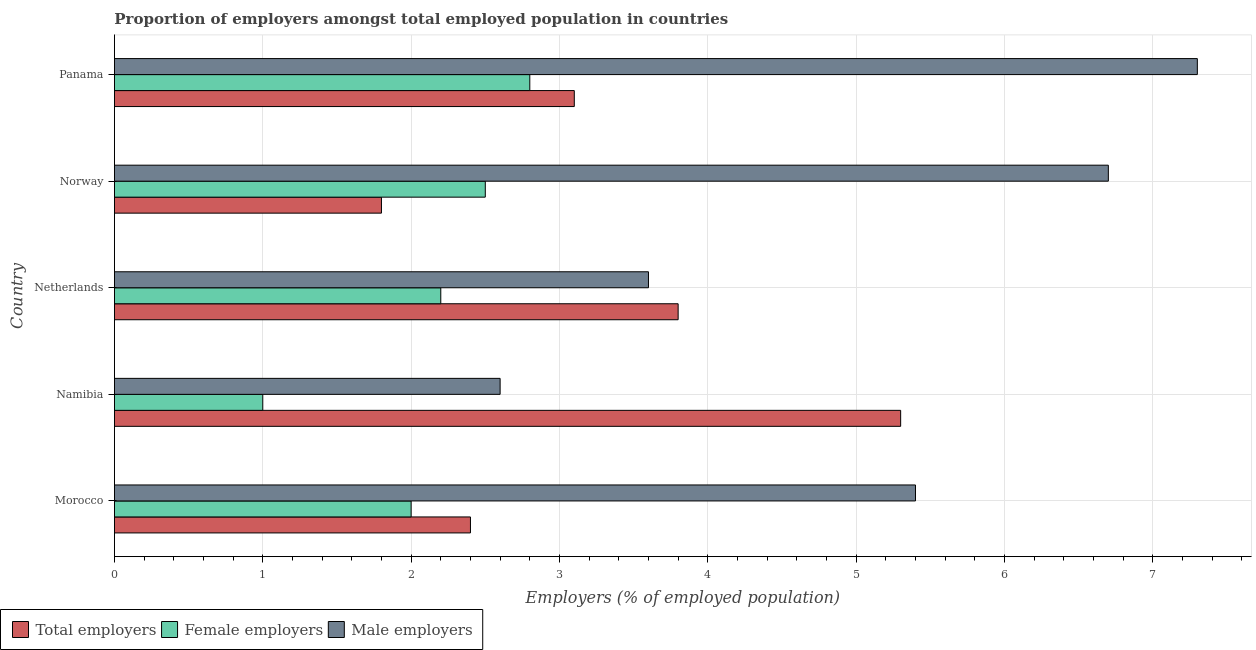How many groups of bars are there?
Ensure brevity in your answer.  5. Are the number of bars on each tick of the Y-axis equal?
Make the answer very short. Yes. How many bars are there on the 4th tick from the bottom?
Make the answer very short. 3. What is the label of the 5th group of bars from the top?
Offer a terse response. Morocco. In how many cases, is the number of bars for a given country not equal to the number of legend labels?
Your answer should be very brief. 0. Across all countries, what is the maximum percentage of total employers?
Offer a very short reply. 5.3. Across all countries, what is the minimum percentage of total employers?
Make the answer very short. 1.8. In which country was the percentage of male employers maximum?
Provide a short and direct response. Panama. In which country was the percentage of male employers minimum?
Your answer should be very brief. Namibia. What is the total percentage of female employers in the graph?
Ensure brevity in your answer.  10.5. What is the difference between the percentage of female employers in Namibia and that in Norway?
Provide a short and direct response. -1.5. What is the difference between the percentage of female employers in Panama and the percentage of total employers in Morocco?
Keep it short and to the point. 0.4. What is the average percentage of total employers per country?
Provide a short and direct response. 3.28. What is the difference between the percentage of female employers and percentage of total employers in Namibia?
Your answer should be very brief. -4.3. In how many countries, is the percentage of female employers greater than 7.4 %?
Your response must be concise. 0. What is the ratio of the percentage of female employers in Netherlands to that in Panama?
Provide a short and direct response. 0.79. Is the percentage of total employers in Namibia less than that in Norway?
Your answer should be compact. No. Is the difference between the percentage of male employers in Morocco and Namibia greater than the difference between the percentage of female employers in Morocco and Namibia?
Provide a succinct answer. Yes. In how many countries, is the percentage of male employers greater than the average percentage of male employers taken over all countries?
Your answer should be very brief. 3. What does the 2nd bar from the top in Netherlands represents?
Ensure brevity in your answer.  Female employers. What does the 2nd bar from the bottom in Netherlands represents?
Offer a terse response. Female employers. How many bars are there?
Ensure brevity in your answer.  15. How many countries are there in the graph?
Your answer should be compact. 5. What is the difference between two consecutive major ticks on the X-axis?
Ensure brevity in your answer.  1. Are the values on the major ticks of X-axis written in scientific E-notation?
Provide a succinct answer. No. How are the legend labels stacked?
Your response must be concise. Horizontal. What is the title of the graph?
Make the answer very short. Proportion of employers amongst total employed population in countries. Does "Grants" appear as one of the legend labels in the graph?
Give a very brief answer. No. What is the label or title of the X-axis?
Offer a very short reply. Employers (% of employed population). What is the Employers (% of employed population) in Total employers in Morocco?
Your answer should be very brief. 2.4. What is the Employers (% of employed population) in Male employers in Morocco?
Your answer should be very brief. 5.4. What is the Employers (% of employed population) in Total employers in Namibia?
Provide a succinct answer. 5.3. What is the Employers (% of employed population) in Male employers in Namibia?
Provide a succinct answer. 2.6. What is the Employers (% of employed population) of Total employers in Netherlands?
Your answer should be compact. 3.8. What is the Employers (% of employed population) in Female employers in Netherlands?
Your response must be concise. 2.2. What is the Employers (% of employed population) of Male employers in Netherlands?
Keep it short and to the point. 3.6. What is the Employers (% of employed population) in Total employers in Norway?
Make the answer very short. 1.8. What is the Employers (% of employed population) in Female employers in Norway?
Your answer should be very brief. 2.5. What is the Employers (% of employed population) of Male employers in Norway?
Keep it short and to the point. 6.7. What is the Employers (% of employed population) in Total employers in Panama?
Your response must be concise. 3.1. What is the Employers (% of employed population) of Female employers in Panama?
Offer a very short reply. 2.8. What is the Employers (% of employed population) in Male employers in Panama?
Keep it short and to the point. 7.3. Across all countries, what is the maximum Employers (% of employed population) in Total employers?
Ensure brevity in your answer.  5.3. Across all countries, what is the maximum Employers (% of employed population) of Female employers?
Your answer should be very brief. 2.8. Across all countries, what is the maximum Employers (% of employed population) in Male employers?
Your answer should be compact. 7.3. Across all countries, what is the minimum Employers (% of employed population) of Total employers?
Give a very brief answer. 1.8. Across all countries, what is the minimum Employers (% of employed population) of Male employers?
Make the answer very short. 2.6. What is the total Employers (% of employed population) of Total employers in the graph?
Offer a terse response. 16.4. What is the total Employers (% of employed population) of Female employers in the graph?
Your answer should be very brief. 10.5. What is the total Employers (% of employed population) of Male employers in the graph?
Offer a very short reply. 25.6. What is the difference between the Employers (% of employed population) in Female employers in Morocco and that in Netherlands?
Provide a succinct answer. -0.2. What is the difference between the Employers (% of employed population) of Total employers in Morocco and that in Norway?
Ensure brevity in your answer.  0.6. What is the difference between the Employers (% of employed population) of Female employers in Morocco and that in Norway?
Your answer should be compact. -0.5. What is the difference between the Employers (% of employed population) of Male employers in Morocco and that in Norway?
Your response must be concise. -1.3. What is the difference between the Employers (% of employed population) of Total employers in Morocco and that in Panama?
Make the answer very short. -0.7. What is the difference between the Employers (% of employed population) of Male employers in Morocco and that in Panama?
Provide a succinct answer. -1.9. What is the difference between the Employers (% of employed population) of Female employers in Namibia and that in Netherlands?
Ensure brevity in your answer.  -1.2. What is the difference between the Employers (% of employed population) in Male employers in Namibia and that in Netherlands?
Provide a succinct answer. -1. What is the difference between the Employers (% of employed population) in Male employers in Namibia and that in Norway?
Your answer should be very brief. -4.1. What is the difference between the Employers (% of employed population) of Female employers in Namibia and that in Panama?
Offer a terse response. -1.8. What is the difference between the Employers (% of employed population) in Total employers in Netherlands and that in Norway?
Provide a succinct answer. 2. What is the difference between the Employers (% of employed population) of Male employers in Netherlands and that in Norway?
Provide a short and direct response. -3.1. What is the difference between the Employers (% of employed population) in Female employers in Netherlands and that in Panama?
Keep it short and to the point. -0.6. What is the difference between the Employers (% of employed population) in Total employers in Norway and that in Panama?
Provide a succinct answer. -1.3. What is the difference between the Employers (% of employed population) in Male employers in Norway and that in Panama?
Ensure brevity in your answer.  -0.6. What is the difference between the Employers (% of employed population) of Total employers in Morocco and the Employers (% of employed population) of Male employers in Namibia?
Provide a succinct answer. -0.2. What is the difference between the Employers (% of employed population) of Female employers in Morocco and the Employers (% of employed population) of Male employers in Namibia?
Offer a terse response. -0.6. What is the difference between the Employers (% of employed population) in Total employers in Morocco and the Employers (% of employed population) in Female employers in Netherlands?
Make the answer very short. 0.2. What is the difference between the Employers (% of employed population) in Female employers in Morocco and the Employers (% of employed population) in Male employers in Netherlands?
Provide a short and direct response. -1.6. What is the difference between the Employers (% of employed population) in Total employers in Morocco and the Employers (% of employed population) in Female employers in Norway?
Offer a terse response. -0.1. What is the difference between the Employers (% of employed population) in Total employers in Morocco and the Employers (% of employed population) in Female employers in Panama?
Your answer should be compact. -0.4. What is the difference between the Employers (% of employed population) of Female employers in Morocco and the Employers (% of employed population) of Male employers in Panama?
Ensure brevity in your answer.  -5.3. What is the difference between the Employers (% of employed population) in Total employers in Namibia and the Employers (% of employed population) in Female employers in Netherlands?
Offer a very short reply. 3.1. What is the difference between the Employers (% of employed population) in Female employers in Namibia and the Employers (% of employed population) in Male employers in Netherlands?
Provide a succinct answer. -2.6. What is the difference between the Employers (% of employed population) in Total employers in Namibia and the Employers (% of employed population) in Female employers in Panama?
Ensure brevity in your answer.  2.5. What is the difference between the Employers (% of employed population) of Total employers in Namibia and the Employers (% of employed population) of Male employers in Panama?
Your response must be concise. -2. What is the difference between the Employers (% of employed population) of Female employers in Namibia and the Employers (% of employed population) of Male employers in Panama?
Make the answer very short. -6.3. What is the difference between the Employers (% of employed population) in Total employers in Netherlands and the Employers (% of employed population) in Male employers in Norway?
Your answer should be very brief. -2.9. What is the difference between the Employers (% of employed population) in Total employers in Netherlands and the Employers (% of employed population) in Female employers in Panama?
Your answer should be very brief. 1. What is the difference between the Employers (% of employed population) in Total employers in Norway and the Employers (% of employed population) in Female employers in Panama?
Your response must be concise. -1. What is the average Employers (% of employed population) of Total employers per country?
Make the answer very short. 3.28. What is the average Employers (% of employed population) of Male employers per country?
Provide a short and direct response. 5.12. What is the difference between the Employers (% of employed population) in Total employers and Employers (% of employed population) in Male employers in Morocco?
Offer a very short reply. -3. What is the difference between the Employers (% of employed population) of Total employers and Employers (% of employed population) of Male employers in Namibia?
Make the answer very short. 2.7. What is the difference between the Employers (% of employed population) of Total employers and Employers (% of employed population) of Female employers in Norway?
Make the answer very short. -0.7. What is the difference between the Employers (% of employed population) in Female employers and Employers (% of employed population) in Male employers in Norway?
Your answer should be compact. -4.2. What is the ratio of the Employers (% of employed population) in Total employers in Morocco to that in Namibia?
Keep it short and to the point. 0.45. What is the ratio of the Employers (% of employed population) in Female employers in Morocco to that in Namibia?
Offer a terse response. 2. What is the ratio of the Employers (% of employed population) in Male employers in Morocco to that in Namibia?
Your answer should be very brief. 2.08. What is the ratio of the Employers (% of employed population) in Total employers in Morocco to that in Netherlands?
Provide a succinct answer. 0.63. What is the ratio of the Employers (% of employed population) of Female employers in Morocco to that in Netherlands?
Provide a short and direct response. 0.91. What is the ratio of the Employers (% of employed population) in Male employers in Morocco to that in Netherlands?
Your answer should be very brief. 1.5. What is the ratio of the Employers (% of employed population) in Male employers in Morocco to that in Norway?
Offer a terse response. 0.81. What is the ratio of the Employers (% of employed population) of Total employers in Morocco to that in Panama?
Provide a succinct answer. 0.77. What is the ratio of the Employers (% of employed population) of Female employers in Morocco to that in Panama?
Your answer should be very brief. 0.71. What is the ratio of the Employers (% of employed population) in Male employers in Morocco to that in Panama?
Ensure brevity in your answer.  0.74. What is the ratio of the Employers (% of employed population) of Total employers in Namibia to that in Netherlands?
Your response must be concise. 1.39. What is the ratio of the Employers (% of employed population) of Female employers in Namibia to that in Netherlands?
Provide a succinct answer. 0.45. What is the ratio of the Employers (% of employed population) of Male employers in Namibia to that in Netherlands?
Give a very brief answer. 0.72. What is the ratio of the Employers (% of employed population) in Total employers in Namibia to that in Norway?
Offer a very short reply. 2.94. What is the ratio of the Employers (% of employed population) of Female employers in Namibia to that in Norway?
Offer a terse response. 0.4. What is the ratio of the Employers (% of employed population) of Male employers in Namibia to that in Norway?
Offer a very short reply. 0.39. What is the ratio of the Employers (% of employed population) of Total employers in Namibia to that in Panama?
Your response must be concise. 1.71. What is the ratio of the Employers (% of employed population) of Female employers in Namibia to that in Panama?
Your answer should be very brief. 0.36. What is the ratio of the Employers (% of employed population) of Male employers in Namibia to that in Panama?
Keep it short and to the point. 0.36. What is the ratio of the Employers (% of employed population) of Total employers in Netherlands to that in Norway?
Offer a terse response. 2.11. What is the ratio of the Employers (% of employed population) in Male employers in Netherlands to that in Norway?
Keep it short and to the point. 0.54. What is the ratio of the Employers (% of employed population) of Total employers in Netherlands to that in Panama?
Offer a terse response. 1.23. What is the ratio of the Employers (% of employed population) in Female employers in Netherlands to that in Panama?
Your answer should be very brief. 0.79. What is the ratio of the Employers (% of employed population) of Male employers in Netherlands to that in Panama?
Provide a short and direct response. 0.49. What is the ratio of the Employers (% of employed population) of Total employers in Norway to that in Panama?
Your answer should be compact. 0.58. What is the ratio of the Employers (% of employed population) in Female employers in Norway to that in Panama?
Provide a succinct answer. 0.89. What is the ratio of the Employers (% of employed population) of Male employers in Norway to that in Panama?
Offer a very short reply. 0.92. What is the difference between the highest and the lowest Employers (% of employed population) in Male employers?
Your answer should be very brief. 4.7. 